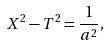<formula> <loc_0><loc_0><loc_500><loc_500>X ^ { 2 } - T ^ { 2 } = \frac { 1 } { a ^ { 2 } } ,</formula> 